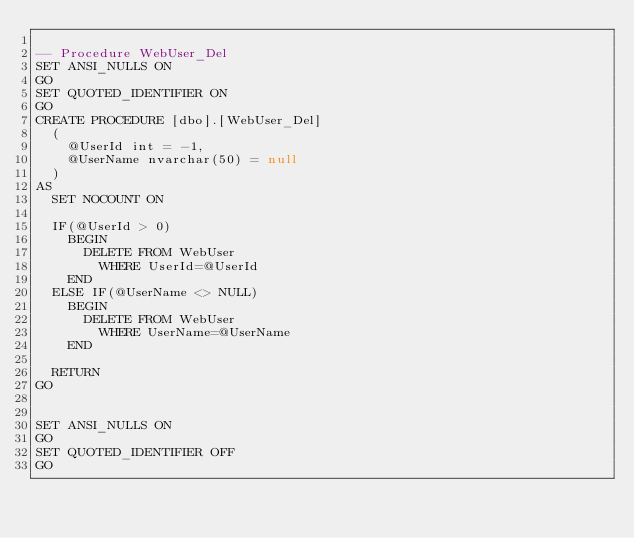<code> <loc_0><loc_0><loc_500><loc_500><_SQL_>
-- Procedure WebUser_Del
SET ANSI_NULLS ON
GO
SET QUOTED_IDENTIFIER ON
GO
CREATE PROCEDURE [dbo].[WebUser_Del]
	(
		@UserId int = -1,
		@UserName nvarchar(50) = null
	)
AS
	SET NOCOUNT ON
	
	IF(@UserId > 0)
		BEGIN
			DELETE FROM WebUser 
				WHERE UserId=@UserId
		END
	ELSE IF(@UserName <> NULL)
		BEGIN
			DELETE FROM WebUser 
				WHERE UserName=@UserName
		END
		
	RETURN
GO


SET ANSI_NULLS ON
GO
SET QUOTED_IDENTIFIER OFF
GO

</code> 